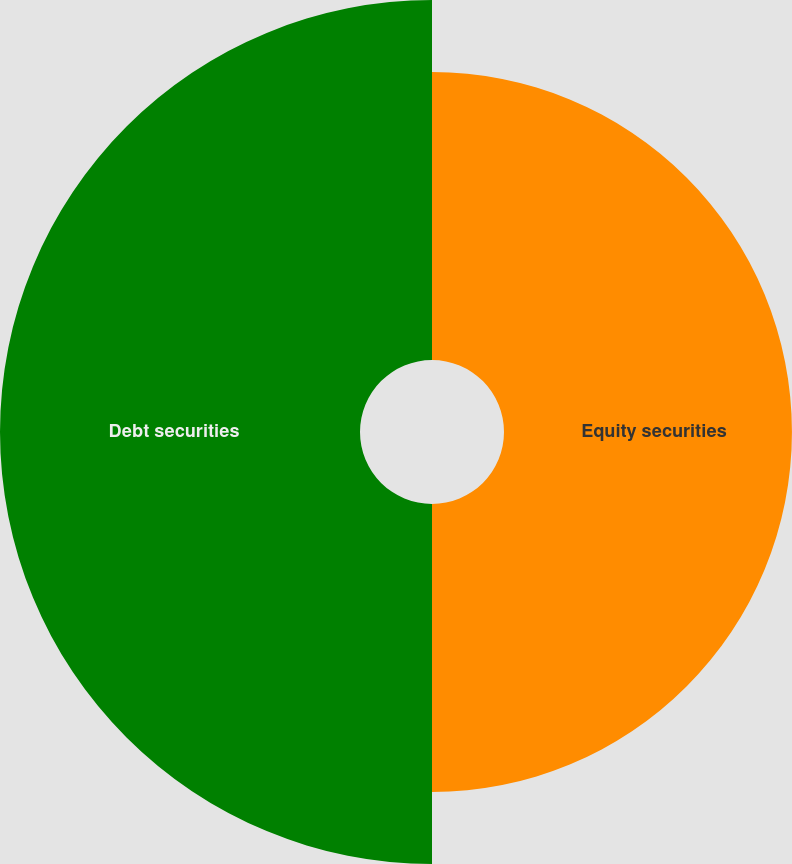Convert chart. <chart><loc_0><loc_0><loc_500><loc_500><pie_chart><fcel>Equity securities<fcel>Debt securities<nl><fcel>44.44%<fcel>55.56%<nl></chart> 